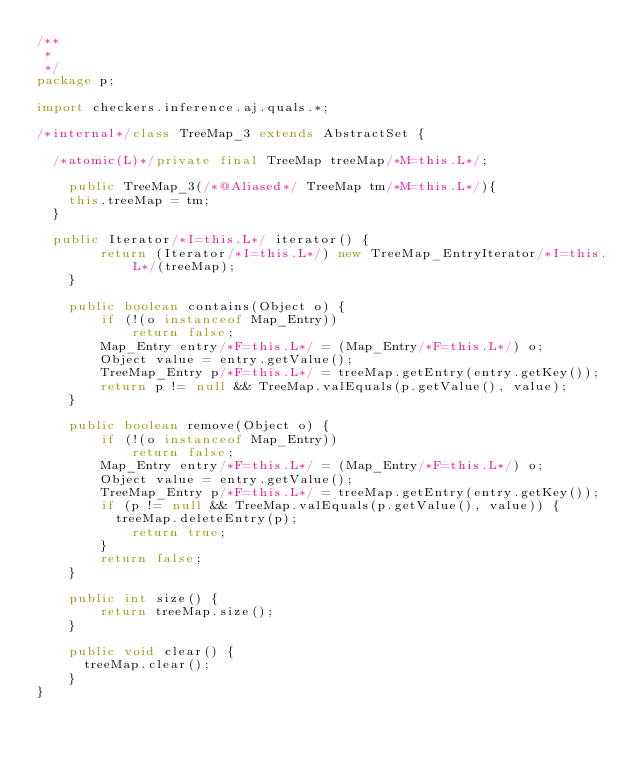<code> <loc_0><loc_0><loc_500><loc_500><_Java_>/**
 * 
 */
package p;

import checkers.inference.aj.quals.*;

/*internal*/class TreeMap_3 extends AbstractSet {
	
	/*atomic(L)*/private final TreeMap treeMap/*M=this.L*/;
	
    public TreeMap_3(/*@Aliased*/ TreeMap tm/*M=this.L*/){
		this.treeMap = tm;
	}
	
	public Iterator/*I=this.L*/ iterator() {
        return (Iterator/*I=this.L*/) new TreeMap_EntryIterator/*I=this.L*/(treeMap);
    }

    public boolean contains(Object o) {
        if (!(o instanceof Map_Entry))
            return false;
        Map_Entry entry/*F=this.L*/ = (Map_Entry/*F=this.L*/) o;
        Object value = entry.getValue();
        TreeMap_Entry p/*F=this.L*/ = treeMap.getEntry(entry.getKey());
        return p != null && TreeMap.valEquals(p.getValue(), value);
    }

    public boolean remove(Object o) {
        if (!(o instanceof Map_Entry))
            return false;
        Map_Entry entry/*F=this.L*/ = (Map_Entry/*F=this.L*/) o;
        Object value = entry.getValue();
        TreeMap_Entry p/*F=this.L*/ = treeMap.getEntry(entry.getKey());
        if (p != null && TreeMap.valEquals(p.getValue(), value)) {
        	treeMap.deleteEntry(p);
            return true;
        }
        return false;
    }

    public int size() {
        return treeMap.size();
    }

    public void clear() {
    	treeMap.clear();
    }
}
</code> 